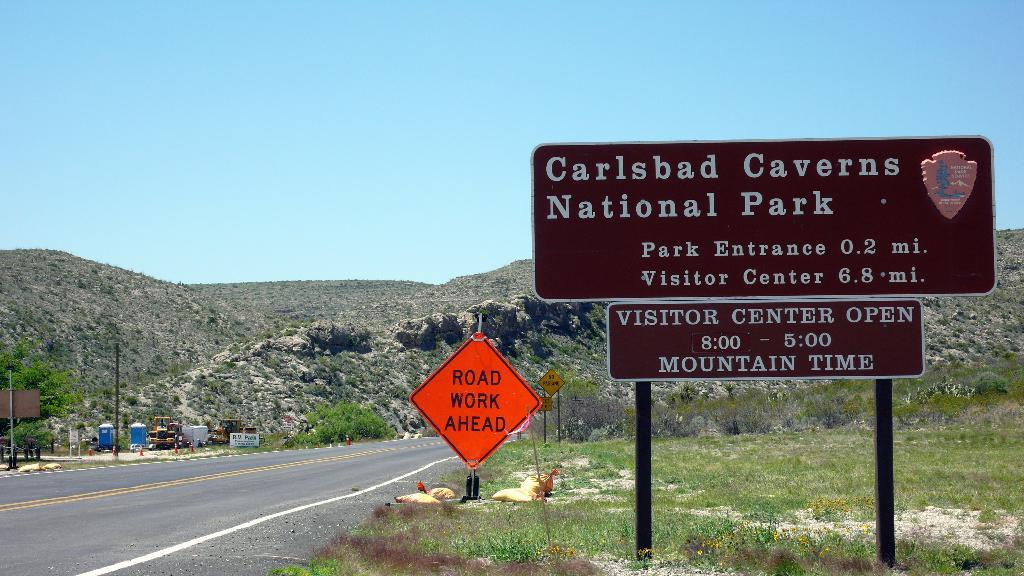Provide a one-sentence caption for the provided image. A road leads to the entrance of Carlsbad Caverns National Park. 